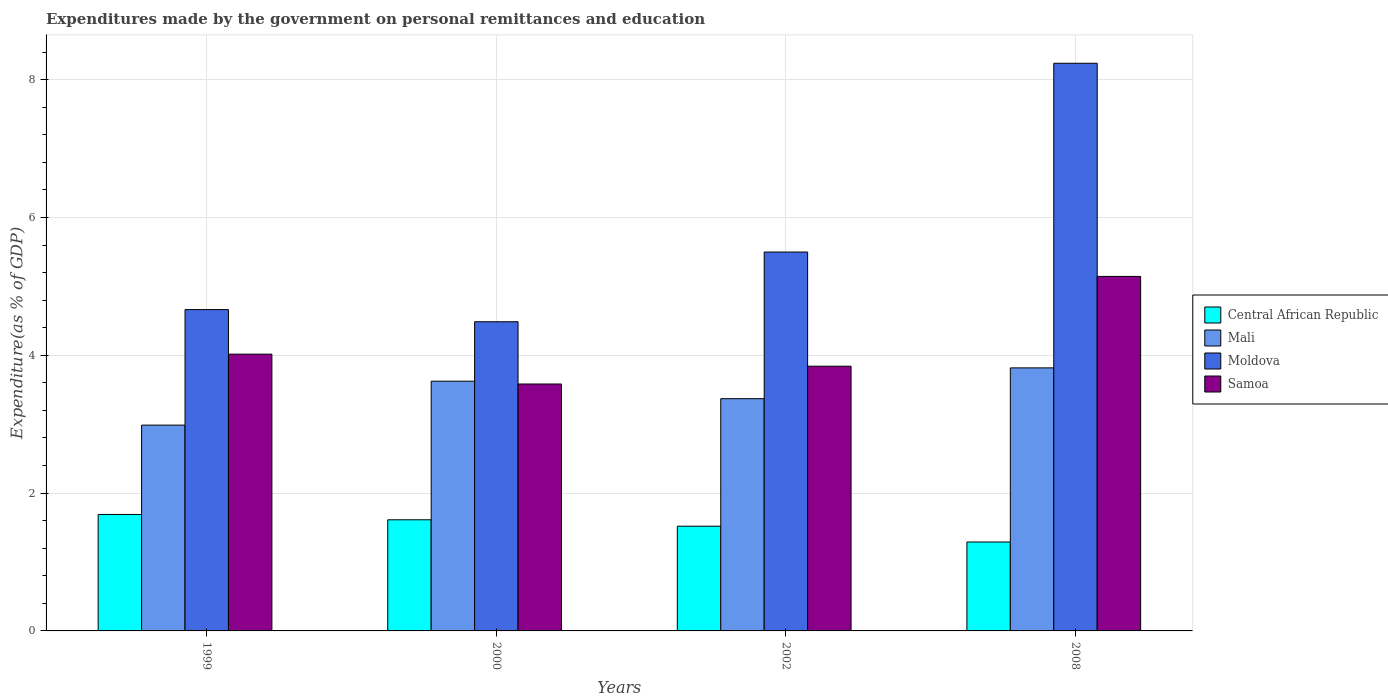How many groups of bars are there?
Give a very brief answer. 4. Are the number of bars per tick equal to the number of legend labels?
Offer a terse response. Yes. Are the number of bars on each tick of the X-axis equal?
Keep it short and to the point. Yes. In how many cases, is the number of bars for a given year not equal to the number of legend labels?
Provide a succinct answer. 0. What is the expenditures made by the government on personal remittances and education in Samoa in 2008?
Your answer should be compact. 5.14. Across all years, what is the maximum expenditures made by the government on personal remittances and education in Central African Republic?
Offer a very short reply. 1.69. Across all years, what is the minimum expenditures made by the government on personal remittances and education in Central African Republic?
Your answer should be very brief. 1.29. In which year was the expenditures made by the government on personal remittances and education in Mali maximum?
Keep it short and to the point. 2008. What is the total expenditures made by the government on personal remittances and education in Central African Republic in the graph?
Your answer should be compact. 6.11. What is the difference between the expenditures made by the government on personal remittances and education in Mali in 1999 and that in 2002?
Offer a very short reply. -0.38. What is the difference between the expenditures made by the government on personal remittances and education in Moldova in 2008 and the expenditures made by the government on personal remittances and education in Central African Republic in 2002?
Your answer should be very brief. 6.72. What is the average expenditures made by the government on personal remittances and education in Central African Republic per year?
Make the answer very short. 1.53. In the year 2000, what is the difference between the expenditures made by the government on personal remittances and education in Samoa and expenditures made by the government on personal remittances and education in Mali?
Keep it short and to the point. -0.04. What is the ratio of the expenditures made by the government on personal remittances and education in Samoa in 1999 to that in 2002?
Ensure brevity in your answer.  1.05. Is the difference between the expenditures made by the government on personal remittances and education in Samoa in 1999 and 2002 greater than the difference between the expenditures made by the government on personal remittances and education in Mali in 1999 and 2002?
Your response must be concise. Yes. What is the difference between the highest and the second highest expenditures made by the government on personal remittances and education in Samoa?
Offer a terse response. 1.13. What is the difference between the highest and the lowest expenditures made by the government on personal remittances and education in Moldova?
Provide a short and direct response. 3.75. In how many years, is the expenditures made by the government on personal remittances and education in Moldova greater than the average expenditures made by the government on personal remittances and education in Moldova taken over all years?
Make the answer very short. 1. Is the sum of the expenditures made by the government on personal remittances and education in Samoa in 1999 and 2000 greater than the maximum expenditures made by the government on personal remittances and education in Mali across all years?
Your answer should be very brief. Yes. What does the 1st bar from the left in 2008 represents?
Offer a very short reply. Central African Republic. What does the 4th bar from the right in 1999 represents?
Give a very brief answer. Central African Republic. How many bars are there?
Provide a succinct answer. 16. Are all the bars in the graph horizontal?
Your answer should be very brief. No. Are the values on the major ticks of Y-axis written in scientific E-notation?
Offer a terse response. No. Where does the legend appear in the graph?
Your answer should be compact. Center right. How many legend labels are there?
Your answer should be very brief. 4. How are the legend labels stacked?
Offer a very short reply. Vertical. What is the title of the graph?
Offer a very short reply. Expenditures made by the government on personal remittances and education. Does "Yemen, Rep." appear as one of the legend labels in the graph?
Provide a short and direct response. No. What is the label or title of the X-axis?
Offer a very short reply. Years. What is the label or title of the Y-axis?
Offer a very short reply. Expenditure(as % of GDP). What is the Expenditure(as % of GDP) in Central African Republic in 1999?
Make the answer very short. 1.69. What is the Expenditure(as % of GDP) in Mali in 1999?
Keep it short and to the point. 2.99. What is the Expenditure(as % of GDP) in Moldova in 1999?
Your answer should be compact. 4.66. What is the Expenditure(as % of GDP) in Samoa in 1999?
Your answer should be very brief. 4.02. What is the Expenditure(as % of GDP) of Central African Republic in 2000?
Your answer should be compact. 1.61. What is the Expenditure(as % of GDP) in Mali in 2000?
Your answer should be very brief. 3.62. What is the Expenditure(as % of GDP) of Moldova in 2000?
Offer a very short reply. 4.49. What is the Expenditure(as % of GDP) of Samoa in 2000?
Offer a very short reply. 3.58. What is the Expenditure(as % of GDP) of Central African Republic in 2002?
Your answer should be compact. 1.52. What is the Expenditure(as % of GDP) in Mali in 2002?
Offer a very short reply. 3.37. What is the Expenditure(as % of GDP) of Moldova in 2002?
Your answer should be very brief. 5.5. What is the Expenditure(as % of GDP) of Samoa in 2002?
Your answer should be very brief. 3.84. What is the Expenditure(as % of GDP) in Central African Republic in 2008?
Give a very brief answer. 1.29. What is the Expenditure(as % of GDP) of Mali in 2008?
Your answer should be compact. 3.82. What is the Expenditure(as % of GDP) in Moldova in 2008?
Your answer should be very brief. 8.24. What is the Expenditure(as % of GDP) of Samoa in 2008?
Ensure brevity in your answer.  5.14. Across all years, what is the maximum Expenditure(as % of GDP) in Central African Republic?
Your answer should be very brief. 1.69. Across all years, what is the maximum Expenditure(as % of GDP) of Mali?
Your response must be concise. 3.82. Across all years, what is the maximum Expenditure(as % of GDP) in Moldova?
Give a very brief answer. 8.24. Across all years, what is the maximum Expenditure(as % of GDP) in Samoa?
Your answer should be very brief. 5.14. Across all years, what is the minimum Expenditure(as % of GDP) of Central African Republic?
Offer a very short reply. 1.29. Across all years, what is the minimum Expenditure(as % of GDP) of Mali?
Make the answer very short. 2.99. Across all years, what is the minimum Expenditure(as % of GDP) of Moldova?
Offer a terse response. 4.49. Across all years, what is the minimum Expenditure(as % of GDP) in Samoa?
Give a very brief answer. 3.58. What is the total Expenditure(as % of GDP) of Central African Republic in the graph?
Your answer should be compact. 6.11. What is the total Expenditure(as % of GDP) in Mali in the graph?
Provide a short and direct response. 13.8. What is the total Expenditure(as % of GDP) of Moldova in the graph?
Provide a short and direct response. 22.88. What is the total Expenditure(as % of GDP) of Samoa in the graph?
Offer a very short reply. 16.58. What is the difference between the Expenditure(as % of GDP) in Central African Republic in 1999 and that in 2000?
Make the answer very short. 0.08. What is the difference between the Expenditure(as % of GDP) in Mali in 1999 and that in 2000?
Offer a terse response. -0.64. What is the difference between the Expenditure(as % of GDP) of Moldova in 1999 and that in 2000?
Provide a short and direct response. 0.18. What is the difference between the Expenditure(as % of GDP) of Samoa in 1999 and that in 2000?
Your answer should be compact. 0.43. What is the difference between the Expenditure(as % of GDP) of Central African Republic in 1999 and that in 2002?
Provide a short and direct response. 0.17. What is the difference between the Expenditure(as % of GDP) of Mali in 1999 and that in 2002?
Keep it short and to the point. -0.38. What is the difference between the Expenditure(as % of GDP) in Moldova in 1999 and that in 2002?
Provide a short and direct response. -0.84. What is the difference between the Expenditure(as % of GDP) of Samoa in 1999 and that in 2002?
Your response must be concise. 0.17. What is the difference between the Expenditure(as % of GDP) of Mali in 1999 and that in 2008?
Your answer should be very brief. -0.83. What is the difference between the Expenditure(as % of GDP) of Moldova in 1999 and that in 2008?
Provide a short and direct response. -3.57. What is the difference between the Expenditure(as % of GDP) in Samoa in 1999 and that in 2008?
Your answer should be compact. -1.13. What is the difference between the Expenditure(as % of GDP) in Central African Republic in 2000 and that in 2002?
Provide a short and direct response. 0.09. What is the difference between the Expenditure(as % of GDP) in Mali in 2000 and that in 2002?
Keep it short and to the point. 0.25. What is the difference between the Expenditure(as % of GDP) of Moldova in 2000 and that in 2002?
Your response must be concise. -1.01. What is the difference between the Expenditure(as % of GDP) in Samoa in 2000 and that in 2002?
Provide a short and direct response. -0.26. What is the difference between the Expenditure(as % of GDP) of Central African Republic in 2000 and that in 2008?
Your answer should be compact. 0.32. What is the difference between the Expenditure(as % of GDP) in Mali in 2000 and that in 2008?
Provide a succinct answer. -0.19. What is the difference between the Expenditure(as % of GDP) in Moldova in 2000 and that in 2008?
Your answer should be compact. -3.75. What is the difference between the Expenditure(as % of GDP) in Samoa in 2000 and that in 2008?
Ensure brevity in your answer.  -1.56. What is the difference between the Expenditure(as % of GDP) in Central African Republic in 2002 and that in 2008?
Ensure brevity in your answer.  0.23. What is the difference between the Expenditure(as % of GDP) in Mali in 2002 and that in 2008?
Your answer should be very brief. -0.45. What is the difference between the Expenditure(as % of GDP) in Moldova in 2002 and that in 2008?
Ensure brevity in your answer.  -2.74. What is the difference between the Expenditure(as % of GDP) in Samoa in 2002 and that in 2008?
Offer a terse response. -1.3. What is the difference between the Expenditure(as % of GDP) of Central African Republic in 1999 and the Expenditure(as % of GDP) of Mali in 2000?
Your answer should be very brief. -1.93. What is the difference between the Expenditure(as % of GDP) in Central African Republic in 1999 and the Expenditure(as % of GDP) in Moldova in 2000?
Offer a terse response. -2.8. What is the difference between the Expenditure(as % of GDP) in Central African Republic in 1999 and the Expenditure(as % of GDP) in Samoa in 2000?
Your answer should be very brief. -1.89. What is the difference between the Expenditure(as % of GDP) of Mali in 1999 and the Expenditure(as % of GDP) of Samoa in 2000?
Your response must be concise. -0.6. What is the difference between the Expenditure(as % of GDP) in Moldova in 1999 and the Expenditure(as % of GDP) in Samoa in 2000?
Make the answer very short. 1.08. What is the difference between the Expenditure(as % of GDP) of Central African Republic in 1999 and the Expenditure(as % of GDP) of Mali in 2002?
Your response must be concise. -1.68. What is the difference between the Expenditure(as % of GDP) of Central African Republic in 1999 and the Expenditure(as % of GDP) of Moldova in 2002?
Keep it short and to the point. -3.81. What is the difference between the Expenditure(as % of GDP) in Central African Republic in 1999 and the Expenditure(as % of GDP) in Samoa in 2002?
Your answer should be compact. -2.15. What is the difference between the Expenditure(as % of GDP) of Mali in 1999 and the Expenditure(as % of GDP) of Moldova in 2002?
Offer a terse response. -2.51. What is the difference between the Expenditure(as % of GDP) in Mali in 1999 and the Expenditure(as % of GDP) in Samoa in 2002?
Your answer should be very brief. -0.85. What is the difference between the Expenditure(as % of GDP) of Moldova in 1999 and the Expenditure(as % of GDP) of Samoa in 2002?
Ensure brevity in your answer.  0.82. What is the difference between the Expenditure(as % of GDP) in Central African Republic in 1999 and the Expenditure(as % of GDP) in Mali in 2008?
Provide a succinct answer. -2.13. What is the difference between the Expenditure(as % of GDP) of Central African Republic in 1999 and the Expenditure(as % of GDP) of Moldova in 2008?
Give a very brief answer. -6.55. What is the difference between the Expenditure(as % of GDP) of Central African Republic in 1999 and the Expenditure(as % of GDP) of Samoa in 2008?
Offer a very short reply. -3.45. What is the difference between the Expenditure(as % of GDP) in Mali in 1999 and the Expenditure(as % of GDP) in Moldova in 2008?
Your answer should be very brief. -5.25. What is the difference between the Expenditure(as % of GDP) of Mali in 1999 and the Expenditure(as % of GDP) of Samoa in 2008?
Give a very brief answer. -2.16. What is the difference between the Expenditure(as % of GDP) of Moldova in 1999 and the Expenditure(as % of GDP) of Samoa in 2008?
Ensure brevity in your answer.  -0.48. What is the difference between the Expenditure(as % of GDP) in Central African Republic in 2000 and the Expenditure(as % of GDP) in Mali in 2002?
Keep it short and to the point. -1.76. What is the difference between the Expenditure(as % of GDP) of Central African Republic in 2000 and the Expenditure(as % of GDP) of Moldova in 2002?
Give a very brief answer. -3.89. What is the difference between the Expenditure(as % of GDP) of Central African Republic in 2000 and the Expenditure(as % of GDP) of Samoa in 2002?
Keep it short and to the point. -2.23. What is the difference between the Expenditure(as % of GDP) in Mali in 2000 and the Expenditure(as % of GDP) in Moldova in 2002?
Ensure brevity in your answer.  -1.87. What is the difference between the Expenditure(as % of GDP) of Mali in 2000 and the Expenditure(as % of GDP) of Samoa in 2002?
Ensure brevity in your answer.  -0.22. What is the difference between the Expenditure(as % of GDP) of Moldova in 2000 and the Expenditure(as % of GDP) of Samoa in 2002?
Make the answer very short. 0.65. What is the difference between the Expenditure(as % of GDP) of Central African Republic in 2000 and the Expenditure(as % of GDP) of Mali in 2008?
Provide a short and direct response. -2.2. What is the difference between the Expenditure(as % of GDP) in Central African Republic in 2000 and the Expenditure(as % of GDP) in Moldova in 2008?
Offer a very short reply. -6.62. What is the difference between the Expenditure(as % of GDP) of Central African Republic in 2000 and the Expenditure(as % of GDP) of Samoa in 2008?
Your response must be concise. -3.53. What is the difference between the Expenditure(as % of GDP) in Mali in 2000 and the Expenditure(as % of GDP) in Moldova in 2008?
Offer a terse response. -4.61. What is the difference between the Expenditure(as % of GDP) in Mali in 2000 and the Expenditure(as % of GDP) in Samoa in 2008?
Provide a short and direct response. -1.52. What is the difference between the Expenditure(as % of GDP) of Moldova in 2000 and the Expenditure(as % of GDP) of Samoa in 2008?
Provide a short and direct response. -0.66. What is the difference between the Expenditure(as % of GDP) of Central African Republic in 2002 and the Expenditure(as % of GDP) of Mali in 2008?
Keep it short and to the point. -2.3. What is the difference between the Expenditure(as % of GDP) in Central African Republic in 2002 and the Expenditure(as % of GDP) in Moldova in 2008?
Give a very brief answer. -6.72. What is the difference between the Expenditure(as % of GDP) in Central African Republic in 2002 and the Expenditure(as % of GDP) in Samoa in 2008?
Your answer should be compact. -3.62. What is the difference between the Expenditure(as % of GDP) in Mali in 2002 and the Expenditure(as % of GDP) in Moldova in 2008?
Your answer should be very brief. -4.87. What is the difference between the Expenditure(as % of GDP) of Mali in 2002 and the Expenditure(as % of GDP) of Samoa in 2008?
Ensure brevity in your answer.  -1.77. What is the difference between the Expenditure(as % of GDP) in Moldova in 2002 and the Expenditure(as % of GDP) in Samoa in 2008?
Your answer should be compact. 0.35. What is the average Expenditure(as % of GDP) of Central African Republic per year?
Provide a short and direct response. 1.53. What is the average Expenditure(as % of GDP) of Mali per year?
Keep it short and to the point. 3.45. What is the average Expenditure(as % of GDP) in Moldova per year?
Offer a very short reply. 5.72. What is the average Expenditure(as % of GDP) of Samoa per year?
Ensure brevity in your answer.  4.15. In the year 1999, what is the difference between the Expenditure(as % of GDP) of Central African Republic and Expenditure(as % of GDP) of Mali?
Your answer should be very brief. -1.3. In the year 1999, what is the difference between the Expenditure(as % of GDP) of Central African Republic and Expenditure(as % of GDP) of Moldova?
Offer a terse response. -2.97. In the year 1999, what is the difference between the Expenditure(as % of GDP) in Central African Republic and Expenditure(as % of GDP) in Samoa?
Your answer should be very brief. -2.33. In the year 1999, what is the difference between the Expenditure(as % of GDP) in Mali and Expenditure(as % of GDP) in Moldova?
Your answer should be very brief. -1.68. In the year 1999, what is the difference between the Expenditure(as % of GDP) of Mali and Expenditure(as % of GDP) of Samoa?
Give a very brief answer. -1.03. In the year 1999, what is the difference between the Expenditure(as % of GDP) in Moldova and Expenditure(as % of GDP) in Samoa?
Your response must be concise. 0.65. In the year 2000, what is the difference between the Expenditure(as % of GDP) of Central African Republic and Expenditure(as % of GDP) of Mali?
Offer a very short reply. -2.01. In the year 2000, what is the difference between the Expenditure(as % of GDP) of Central African Republic and Expenditure(as % of GDP) of Moldova?
Provide a succinct answer. -2.87. In the year 2000, what is the difference between the Expenditure(as % of GDP) of Central African Republic and Expenditure(as % of GDP) of Samoa?
Make the answer very short. -1.97. In the year 2000, what is the difference between the Expenditure(as % of GDP) of Mali and Expenditure(as % of GDP) of Moldova?
Ensure brevity in your answer.  -0.86. In the year 2000, what is the difference between the Expenditure(as % of GDP) in Mali and Expenditure(as % of GDP) in Samoa?
Your answer should be compact. 0.04. In the year 2000, what is the difference between the Expenditure(as % of GDP) of Moldova and Expenditure(as % of GDP) of Samoa?
Make the answer very short. 0.9. In the year 2002, what is the difference between the Expenditure(as % of GDP) in Central African Republic and Expenditure(as % of GDP) in Mali?
Offer a very short reply. -1.85. In the year 2002, what is the difference between the Expenditure(as % of GDP) of Central African Republic and Expenditure(as % of GDP) of Moldova?
Provide a succinct answer. -3.98. In the year 2002, what is the difference between the Expenditure(as % of GDP) in Central African Republic and Expenditure(as % of GDP) in Samoa?
Your response must be concise. -2.32. In the year 2002, what is the difference between the Expenditure(as % of GDP) of Mali and Expenditure(as % of GDP) of Moldova?
Make the answer very short. -2.13. In the year 2002, what is the difference between the Expenditure(as % of GDP) of Mali and Expenditure(as % of GDP) of Samoa?
Provide a succinct answer. -0.47. In the year 2002, what is the difference between the Expenditure(as % of GDP) of Moldova and Expenditure(as % of GDP) of Samoa?
Your answer should be very brief. 1.66. In the year 2008, what is the difference between the Expenditure(as % of GDP) of Central African Republic and Expenditure(as % of GDP) of Mali?
Provide a succinct answer. -2.53. In the year 2008, what is the difference between the Expenditure(as % of GDP) in Central African Republic and Expenditure(as % of GDP) in Moldova?
Give a very brief answer. -6.95. In the year 2008, what is the difference between the Expenditure(as % of GDP) in Central African Republic and Expenditure(as % of GDP) in Samoa?
Keep it short and to the point. -3.85. In the year 2008, what is the difference between the Expenditure(as % of GDP) in Mali and Expenditure(as % of GDP) in Moldova?
Give a very brief answer. -4.42. In the year 2008, what is the difference between the Expenditure(as % of GDP) of Mali and Expenditure(as % of GDP) of Samoa?
Provide a short and direct response. -1.33. In the year 2008, what is the difference between the Expenditure(as % of GDP) in Moldova and Expenditure(as % of GDP) in Samoa?
Provide a short and direct response. 3.09. What is the ratio of the Expenditure(as % of GDP) of Central African Republic in 1999 to that in 2000?
Give a very brief answer. 1.05. What is the ratio of the Expenditure(as % of GDP) of Mali in 1999 to that in 2000?
Give a very brief answer. 0.82. What is the ratio of the Expenditure(as % of GDP) of Moldova in 1999 to that in 2000?
Your response must be concise. 1.04. What is the ratio of the Expenditure(as % of GDP) in Samoa in 1999 to that in 2000?
Make the answer very short. 1.12. What is the ratio of the Expenditure(as % of GDP) in Central African Republic in 1999 to that in 2002?
Keep it short and to the point. 1.11. What is the ratio of the Expenditure(as % of GDP) of Mali in 1999 to that in 2002?
Make the answer very short. 0.89. What is the ratio of the Expenditure(as % of GDP) of Moldova in 1999 to that in 2002?
Ensure brevity in your answer.  0.85. What is the ratio of the Expenditure(as % of GDP) in Samoa in 1999 to that in 2002?
Offer a very short reply. 1.05. What is the ratio of the Expenditure(as % of GDP) of Central African Republic in 1999 to that in 2008?
Provide a short and direct response. 1.31. What is the ratio of the Expenditure(as % of GDP) of Mali in 1999 to that in 2008?
Provide a succinct answer. 0.78. What is the ratio of the Expenditure(as % of GDP) of Moldova in 1999 to that in 2008?
Ensure brevity in your answer.  0.57. What is the ratio of the Expenditure(as % of GDP) of Samoa in 1999 to that in 2008?
Your answer should be very brief. 0.78. What is the ratio of the Expenditure(as % of GDP) of Central African Republic in 2000 to that in 2002?
Offer a terse response. 1.06. What is the ratio of the Expenditure(as % of GDP) of Mali in 2000 to that in 2002?
Your answer should be very brief. 1.08. What is the ratio of the Expenditure(as % of GDP) of Moldova in 2000 to that in 2002?
Make the answer very short. 0.82. What is the ratio of the Expenditure(as % of GDP) of Samoa in 2000 to that in 2002?
Keep it short and to the point. 0.93. What is the ratio of the Expenditure(as % of GDP) of Central African Republic in 2000 to that in 2008?
Offer a very short reply. 1.25. What is the ratio of the Expenditure(as % of GDP) in Mali in 2000 to that in 2008?
Your answer should be compact. 0.95. What is the ratio of the Expenditure(as % of GDP) of Moldova in 2000 to that in 2008?
Your answer should be compact. 0.54. What is the ratio of the Expenditure(as % of GDP) in Samoa in 2000 to that in 2008?
Ensure brevity in your answer.  0.7. What is the ratio of the Expenditure(as % of GDP) in Central African Republic in 2002 to that in 2008?
Make the answer very short. 1.18. What is the ratio of the Expenditure(as % of GDP) in Mali in 2002 to that in 2008?
Keep it short and to the point. 0.88. What is the ratio of the Expenditure(as % of GDP) of Moldova in 2002 to that in 2008?
Offer a terse response. 0.67. What is the ratio of the Expenditure(as % of GDP) in Samoa in 2002 to that in 2008?
Your response must be concise. 0.75. What is the difference between the highest and the second highest Expenditure(as % of GDP) in Central African Republic?
Your response must be concise. 0.08. What is the difference between the highest and the second highest Expenditure(as % of GDP) of Mali?
Your answer should be very brief. 0.19. What is the difference between the highest and the second highest Expenditure(as % of GDP) in Moldova?
Give a very brief answer. 2.74. What is the difference between the highest and the second highest Expenditure(as % of GDP) of Samoa?
Your answer should be compact. 1.13. What is the difference between the highest and the lowest Expenditure(as % of GDP) of Central African Republic?
Give a very brief answer. 0.4. What is the difference between the highest and the lowest Expenditure(as % of GDP) of Mali?
Offer a very short reply. 0.83. What is the difference between the highest and the lowest Expenditure(as % of GDP) in Moldova?
Your answer should be very brief. 3.75. What is the difference between the highest and the lowest Expenditure(as % of GDP) of Samoa?
Provide a short and direct response. 1.56. 